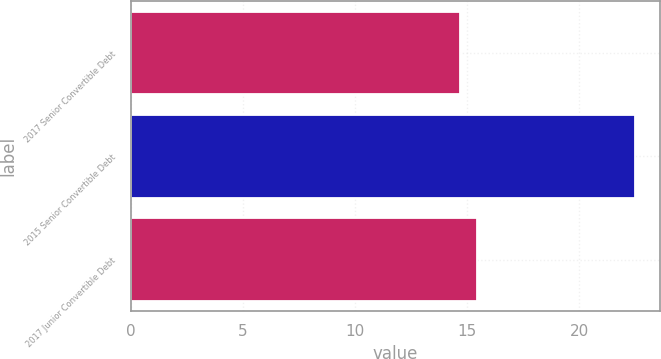<chart> <loc_0><loc_0><loc_500><loc_500><bar_chart><fcel>2017 Senior Convertible Debt<fcel>2015 Senior Convertible Debt<fcel>2017 Junior Convertible Debt<nl><fcel>14.67<fcel>22.47<fcel>15.45<nl></chart> 